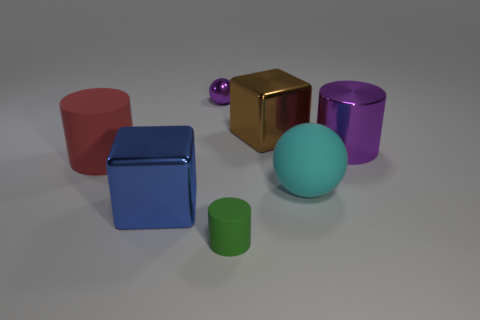Add 2 large purple matte cubes. How many objects exist? 9 Subtract all cubes. How many objects are left? 5 Add 5 large matte cylinders. How many large matte cylinders exist? 6 Subtract 0 gray blocks. How many objects are left? 7 Subtract all yellow rubber cubes. Subtract all purple metal cylinders. How many objects are left? 6 Add 2 cyan things. How many cyan things are left? 3 